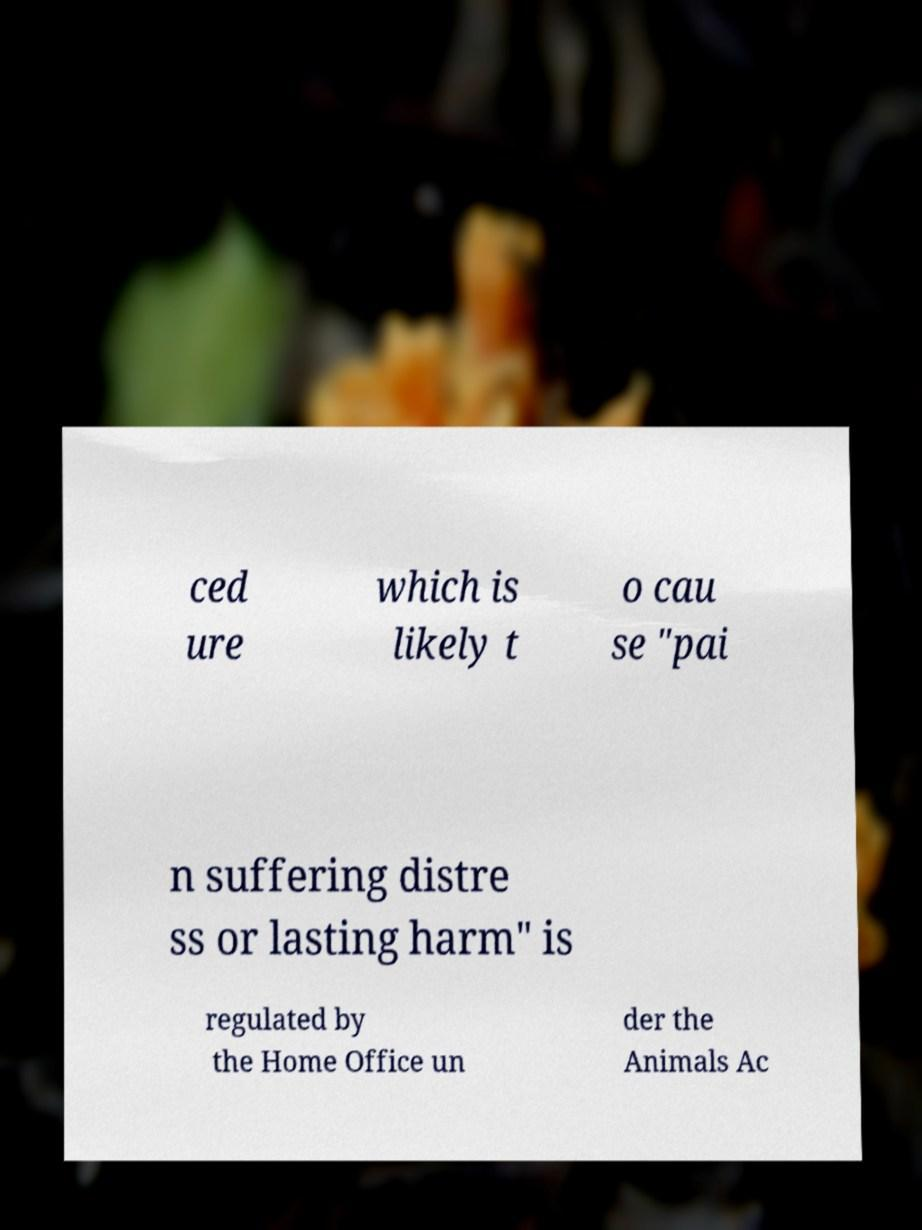Could you assist in decoding the text presented in this image and type it out clearly? ced ure which is likely t o cau se "pai n suffering distre ss or lasting harm" is regulated by the Home Office un der the Animals Ac 